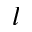<formula> <loc_0><loc_0><loc_500><loc_500>l</formula> 